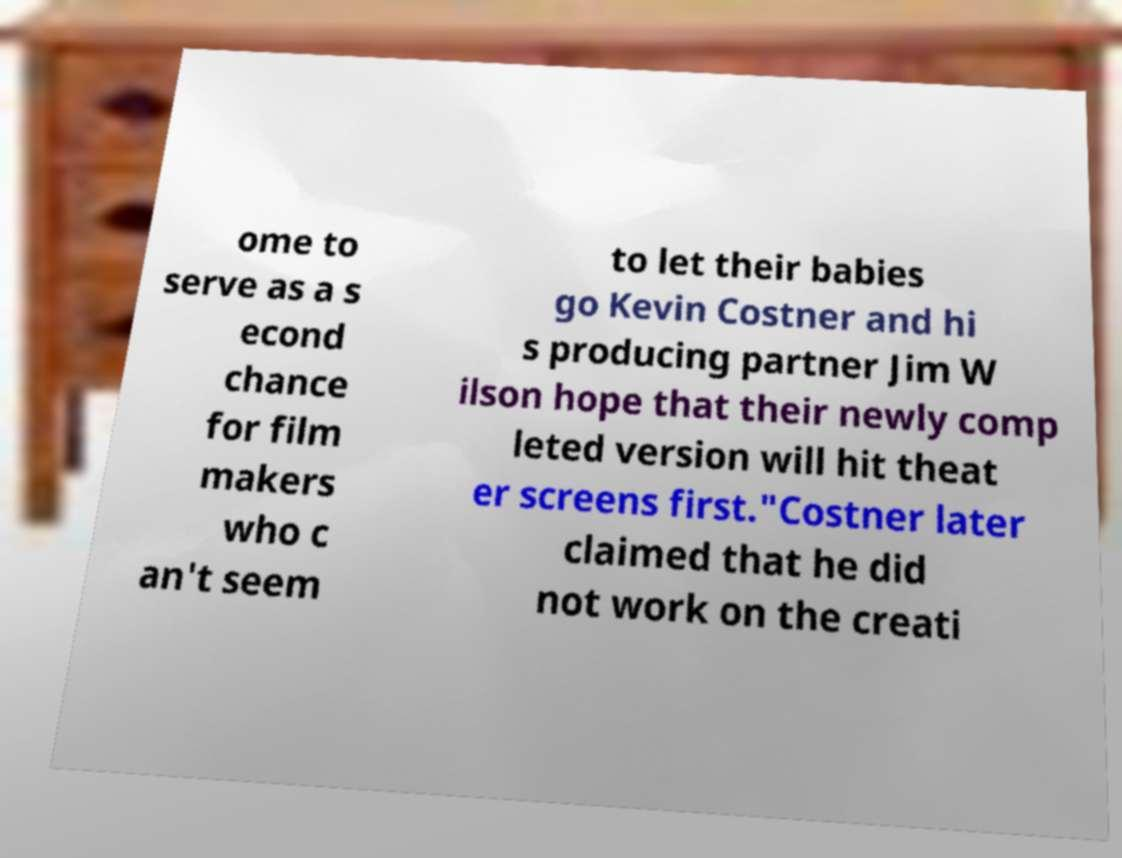Could you extract and type out the text from this image? ome to serve as a s econd chance for film makers who c an't seem to let their babies go Kevin Costner and hi s producing partner Jim W ilson hope that their newly comp leted version will hit theat er screens first."Costner later claimed that he did not work on the creati 